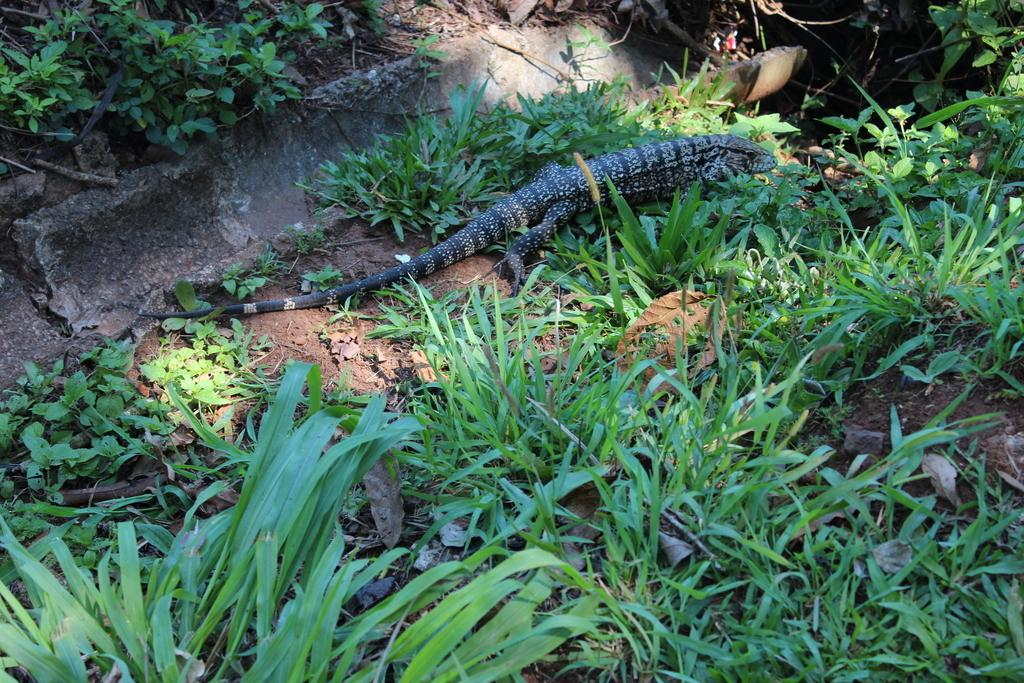What type of animal is in the image? There is a reptile in the image. Where is the reptile located in the image? The reptile is on the ground. What type of vegetation is present in the image? There are small plants and grass in the image. What type of bat is flying over the reptile in the image? There is no bat present in the image; it only features a reptile on the ground and small plants and grass. 